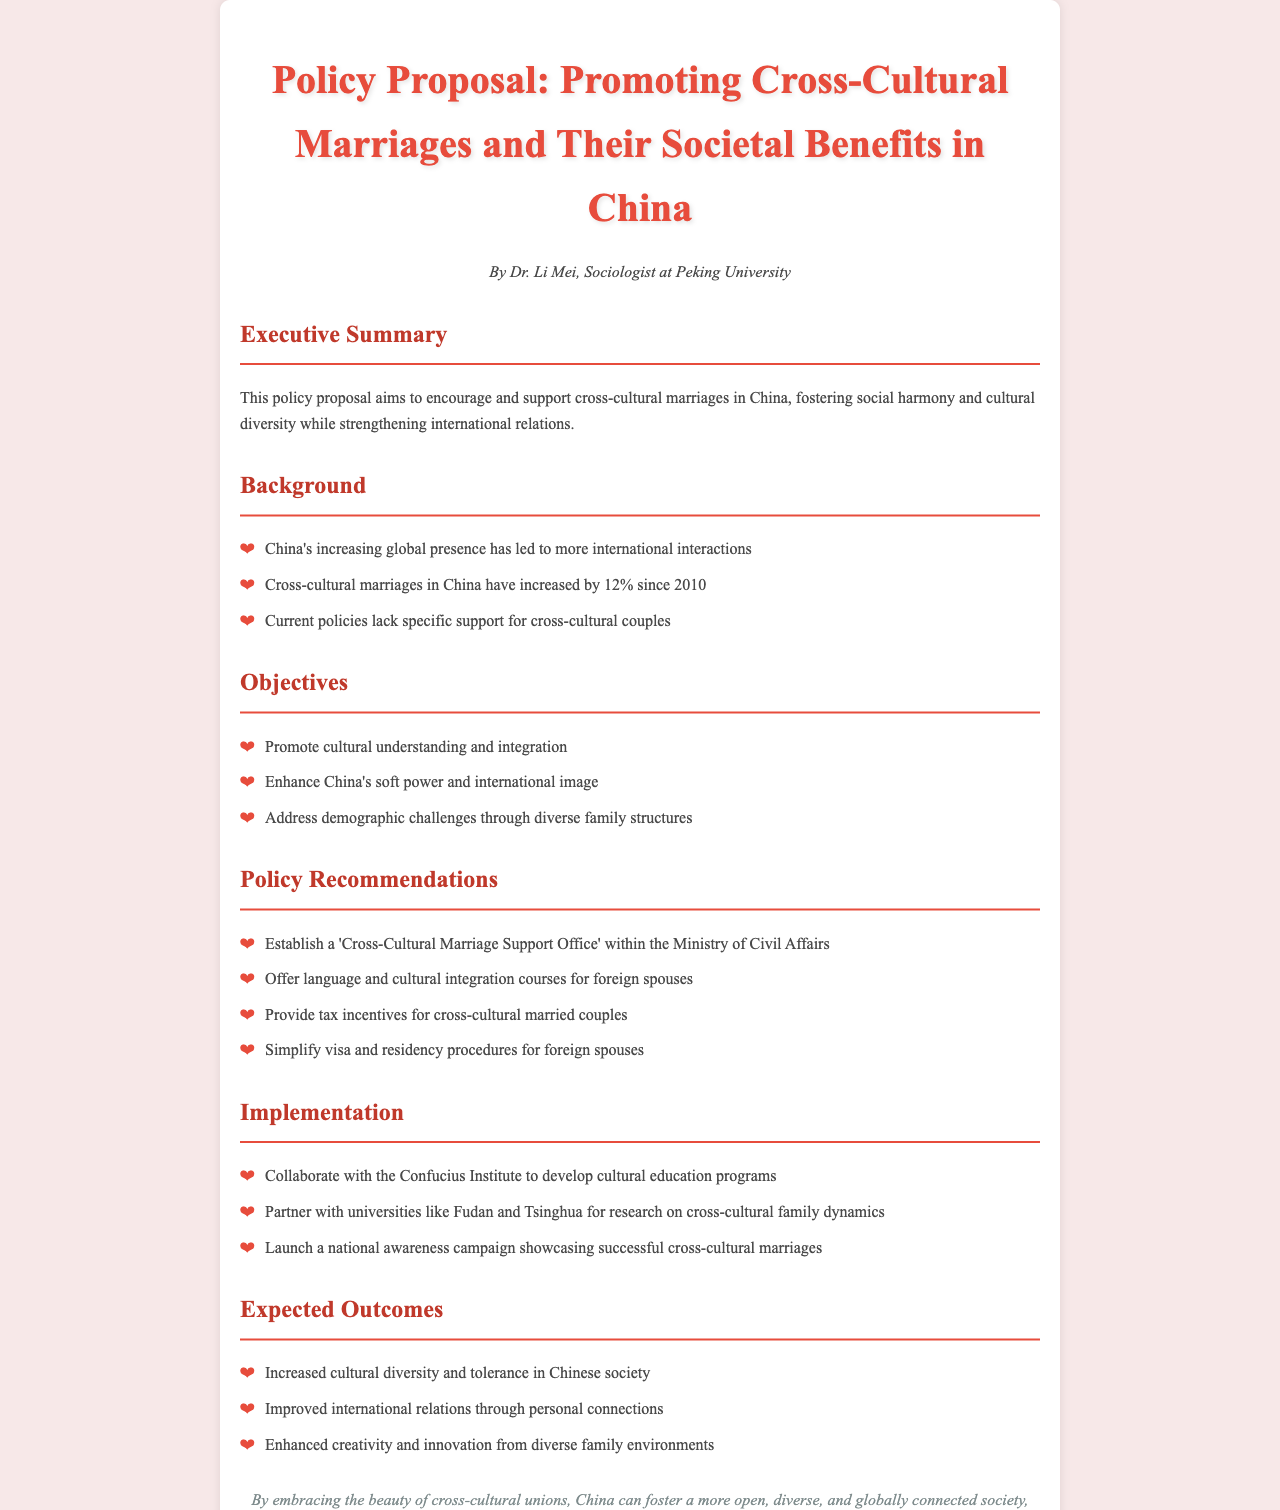What is the title of the policy proposal? The title of the policy proposal is stated clearly at the top of the document.
Answer: Policy Proposal: Promoting Cross-Cultural Marriages and Their Societal Benefits in China Who is the author of the document? The author of the document is identified in the author section.
Answer: Dr. Li Mei What has been the percentage increase in cross-cultural marriages since 2010? The document mentions specific statistics regarding cross-cultural marriages in China.
Answer: 12% What is one of the objectives mentioned in the proposal? The proposal lists specific objectives to be achieved through the policy.
Answer: Promote cultural understanding and integration What office is recommended to be established? The recommendations section of the document suggests the establishment of a specific office.
Answer: Cross-Cultural Marriage Support Office What is one expected outcome of promoting cross-cultural marriages? Expected outcomes are listed in the document, highlighting the benefits of the policy.
Answer: Increased cultural diversity and tolerance in Chinese society Which institutions are suggested for collaboration in the implementation? The implementation section mentions specific universities for collaboration.
Answer: Fudan and Tsinghua What is one recommended support offered to foreign spouses? The recommendations section states specific support measures for foreign spouses.
Answer: Language and cultural integration courses What type of campaign is proposed to create awareness? The implementation section specifies a type of campaign aimed at public awareness.
Answer: National awareness campaign 